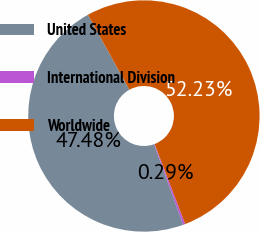<chart> <loc_0><loc_0><loc_500><loc_500><pie_chart><fcel>United States<fcel>International Division<fcel>Worldwide<nl><fcel>47.48%<fcel>0.29%<fcel>52.23%<nl></chart> 